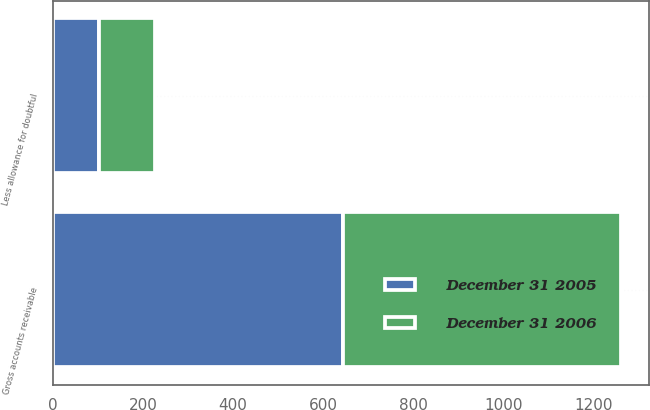<chart> <loc_0><loc_0><loc_500><loc_500><stacked_bar_chart><ecel><fcel>Gross accounts receivable<fcel>Less allowance for doubtful<nl><fcel>December 31 2005<fcel>643.6<fcel>102.3<nl><fcel>December 31 2006<fcel>618<fcel>124.6<nl></chart> 